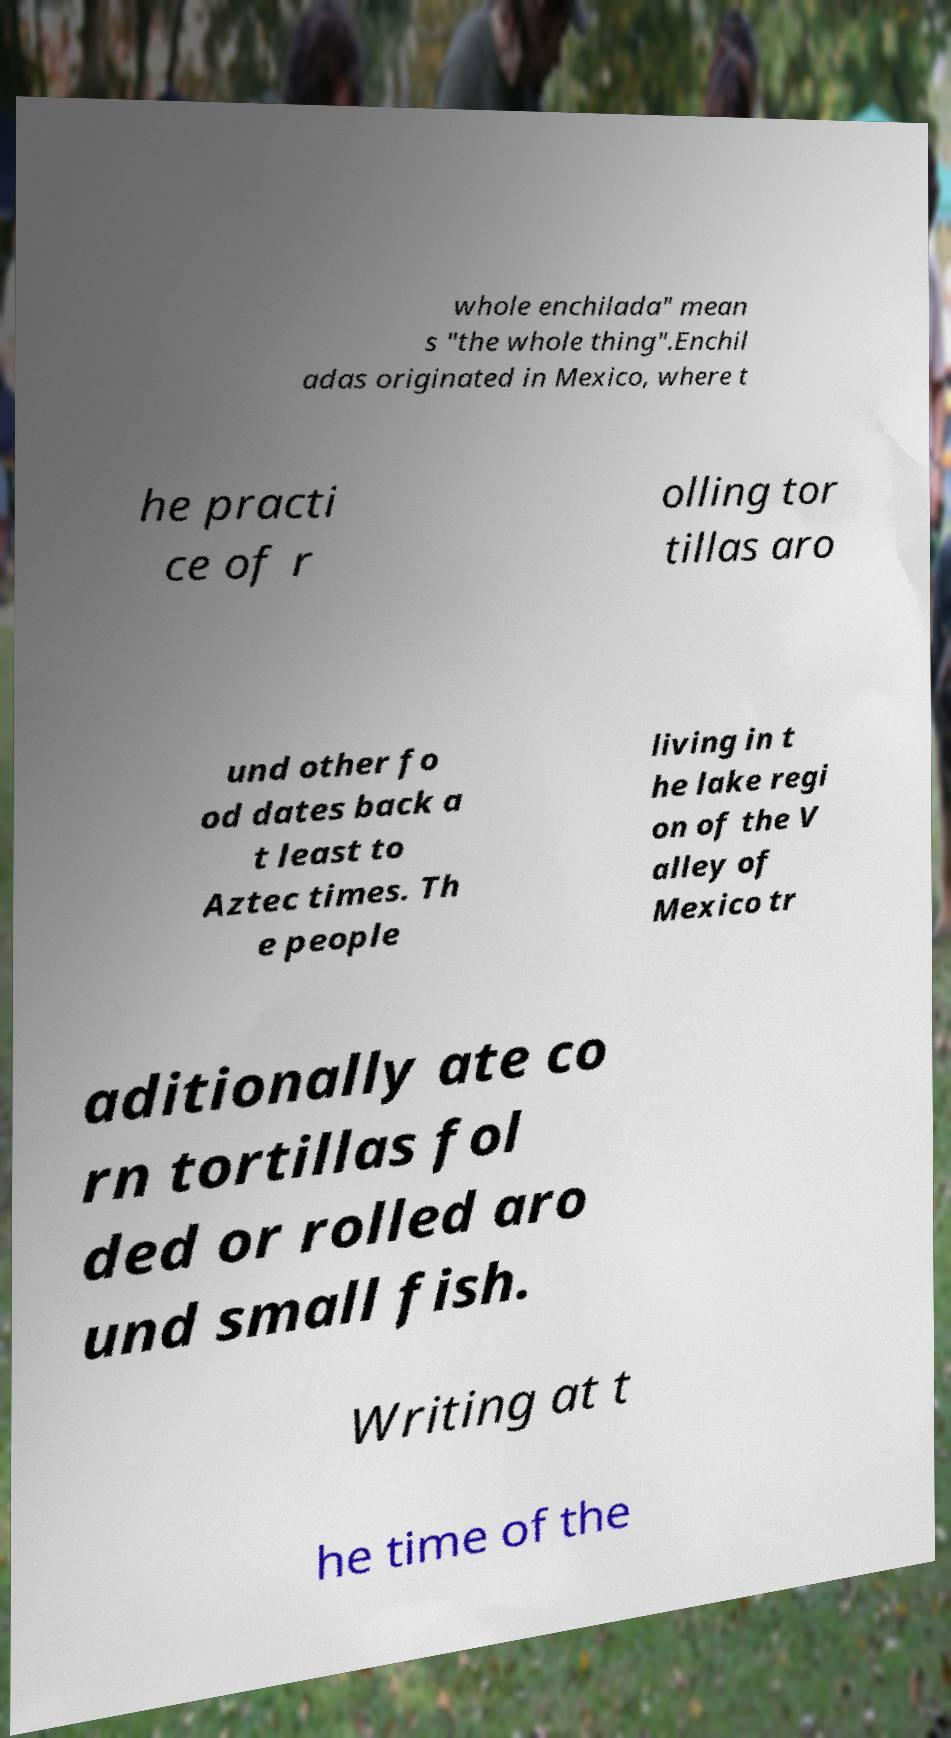Can you read and provide the text displayed in the image?This photo seems to have some interesting text. Can you extract and type it out for me? whole enchilada" mean s "the whole thing".Enchil adas originated in Mexico, where t he practi ce of r olling tor tillas aro und other fo od dates back a t least to Aztec times. Th e people living in t he lake regi on of the V alley of Mexico tr aditionally ate co rn tortillas fol ded or rolled aro und small fish. Writing at t he time of the 